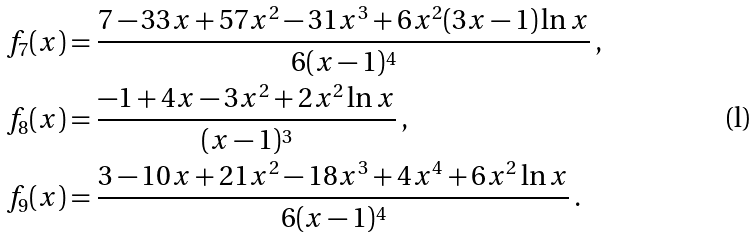<formula> <loc_0><loc_0><loc_500><loc_500>f _ { 7 } ( x ) & = \frac { 7 - 3 3 x + 5 7 x ^ { 2 } - 3 1 x ^ { 3 } + 6 x ^ { 2 } ( 3 x - 1 ) \ln x } { 6 ( x - 1 ) ^ { 4 } } \, , \\ f _ { 8 } ( x ) & = \frac { - 1 + 4 x - 3 x ^ { 2 } + 2 x ^ { 2 } \ln x } { ( x - 1 ) ^ { 3 } } \, , \\ f _ { 9 } ( x ) & = \frac { 3 - 1 0 x + 2 1 x ^ { 2 } - 1 8 x ^ { 3 } + 4 x ^ { 4 } + 6 x ^ { 2 } \ln x } { 6 ( x - 1 ) ^ { 4 } } \, .</formula> 